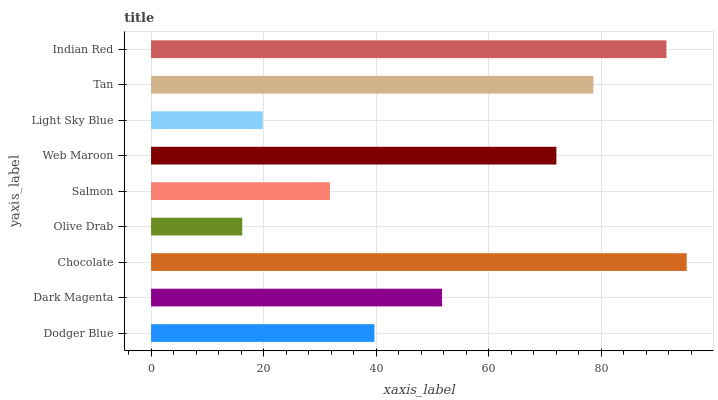Is Olive Drab the minimum?
Answer yes or no. Yes. Is Chocolate the maximum?
Answer yes or no. Yes. Is Dark Magenta the minimum?
Answer yes or no. No. Is Dark Magenta the maximum?
Answer yes or no. No. Is Dark Magenta greater than Dodger Blue?
Answer yes or no. Yes. Is Dodger Blue less than Dark Magenta?
Answer yes or no. Yes. Is Dodger Blue greater than Dark Magenta?
Answer yes or no. No. Is Dark Magenta less than Dodger Blue?
Answer yes or no. No. Is Dark Magenta the high median?
Answer yes or no. Yes. Is Dark Magenta the low median?
Answer yes or no. Yes. Is Olive Drab the high median?
Answer yes or no. No. Is Dodger Blue the low median?
Answer yes or no. No. 